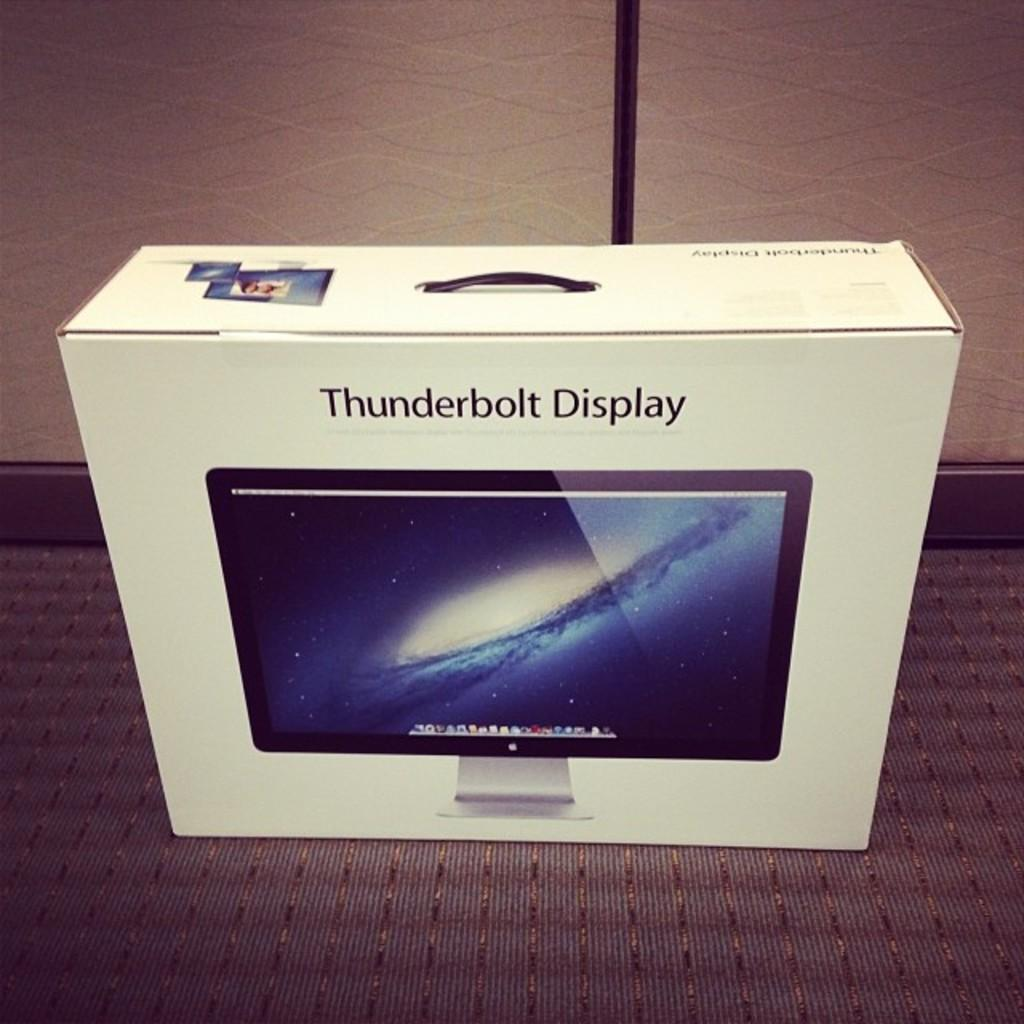<image>
Present a compact description of the photo's key features. A box for a computer monitor that says Thunderbolt Display. 